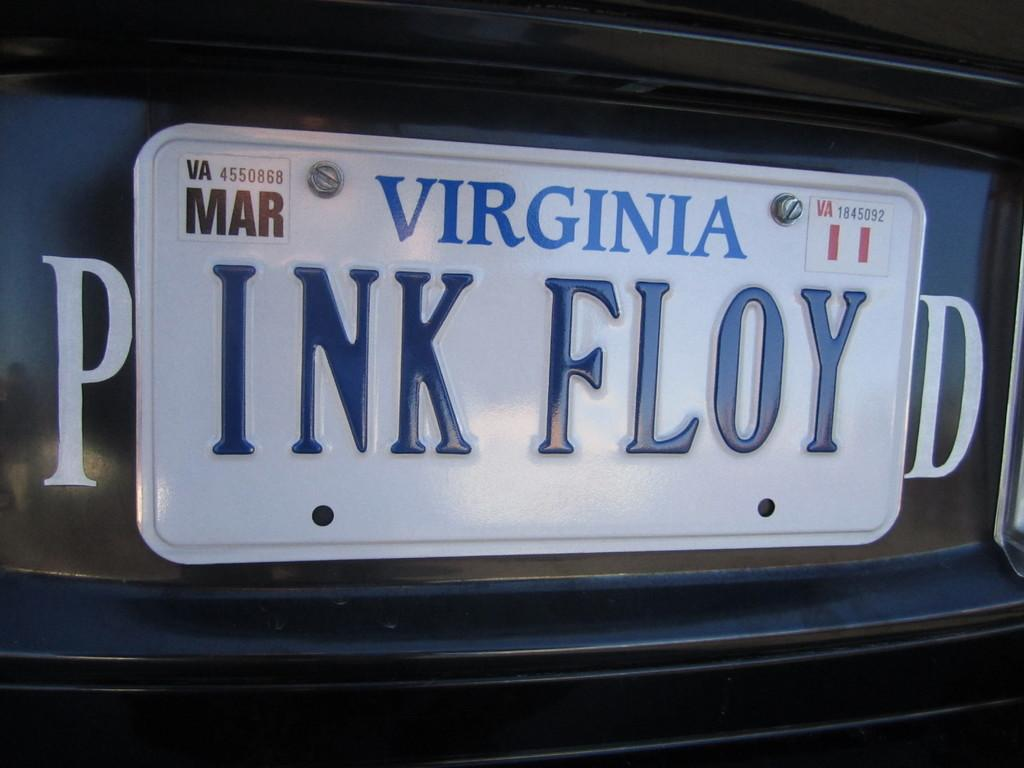<image>
Render a clear and concise summary of the photo. A Virginia tag that reads INK FLOY with a P and a D on the outside of the tag to read PINK FLOYD. 